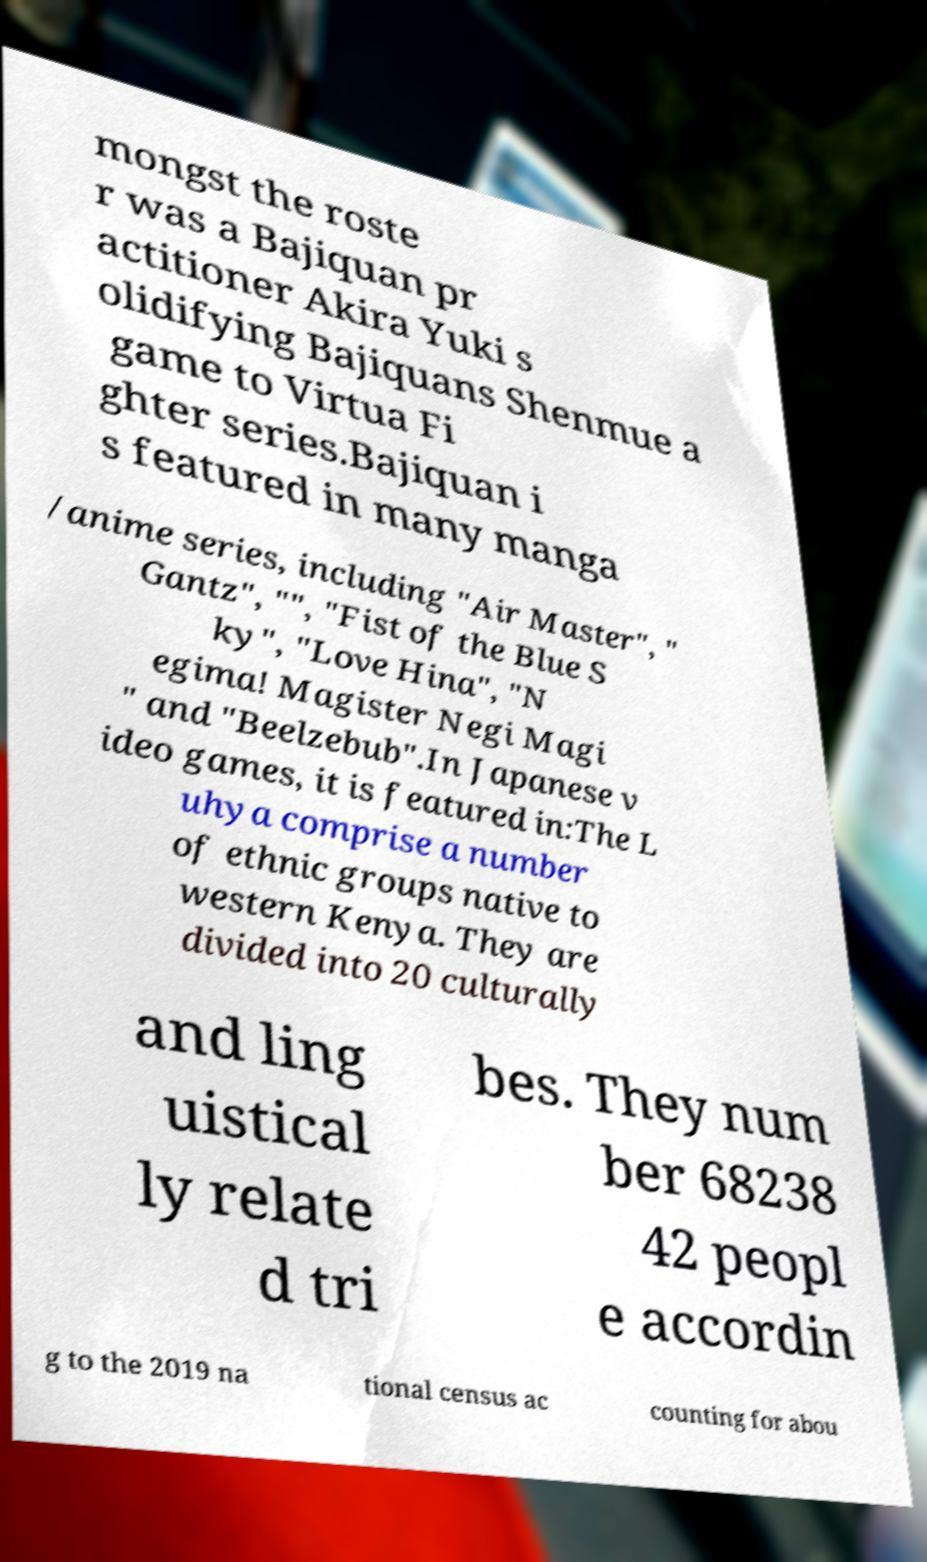I need the written content from this picture converted into text. Can you do that? mongst the roste r was a Bajiquan pr actitioner Akira Yuki s olidifying Bajiquans Shenmue a game to Virtua Fi ghter series.Bajiquan i s featured in many manga /anime series, including "Air Master", " Gantz", "", "Fist of the Blue S ky", "Love Hina", "N egima! Magister Negi Magi " and "Beelzebub".In Japanese v ideo games, it is featured in:The L uhya comprise a number of ethnic groups native to western Kenya. They are divided into 20 culturally and ling uistical ly relate d tri bes. They num ber 68238 42 peopl e accordin g to the 2019 na tional census ac counting for abou 